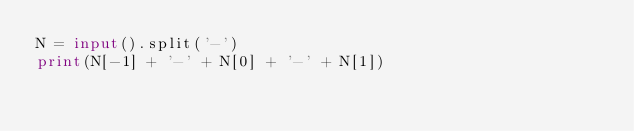Convert code to text. <code><loc_0><loc_0><loc_500><loc_500><_Python_>N = input().split('-')
print(N[-1] + '-' + N[0] + '-' + N[1])
</code> 